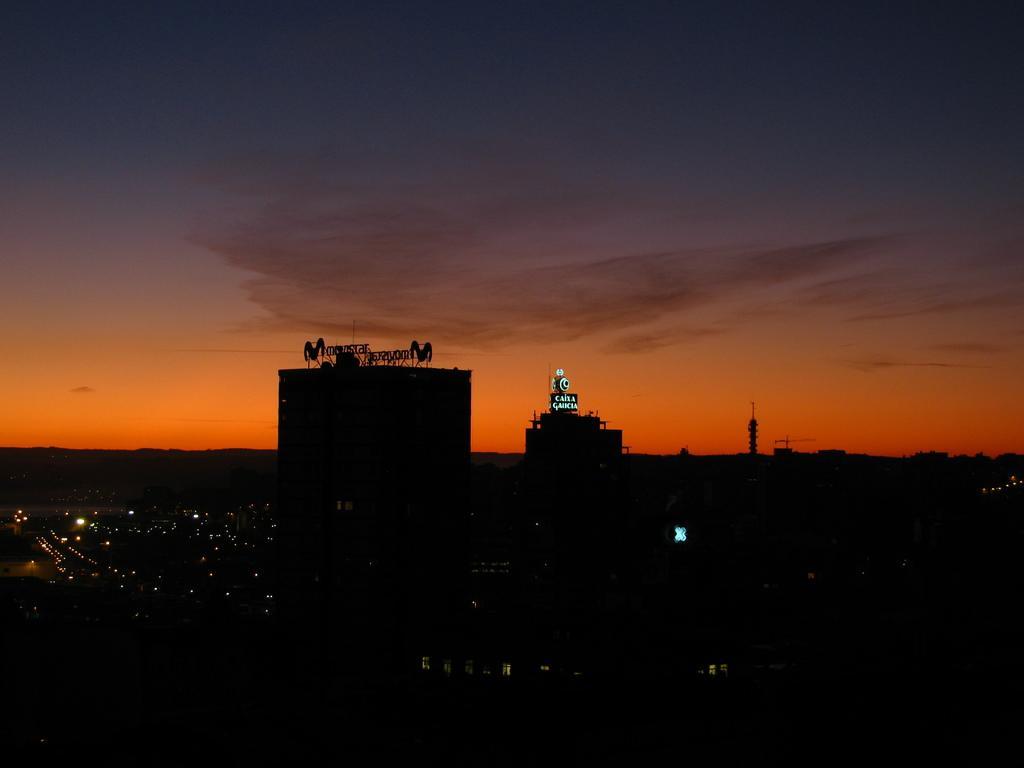Can you describe this image briefly? In this picture we can see buildings and lights and on the buildings there are the name boards. Behind the birds there is the sky. 